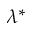Convert formula to latex. <formula><loc_0><loc_0><loc_500><loc_500>\lambda ^ { * }</formula> 